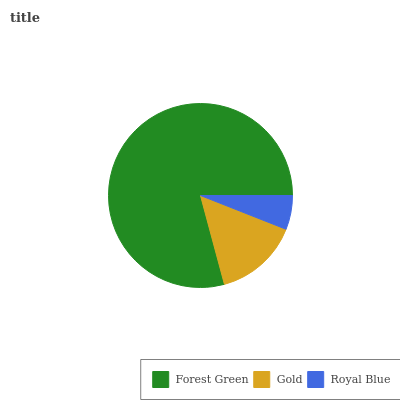Is Royal Blue the minimum?
Answer yes or no. Yes. Is Forest Green the maximum?
Answer yes or no. Yes. Is Gold the minimum?
Answer yes or no. No. Is Gold the maximum?
Answer yes or no. No. Is Forest Green greater than Gold?
Answer yes or no. Yes. Is Gold less than Forest Green?
Answer yes or no. Yes. Is Gold greater than Forest Green?
Answer yes or no. No. Is Forest Green less than Gold?
Answer yes or no. No. Is Gold the high median?
Answer yes or no. Yes. Is Gold the low median?
Answer yes or no. Yes. Is Royal Blue the high median?
Answer yes or no. No. Is Forest Green the low median?
Answer yes or no. No. 